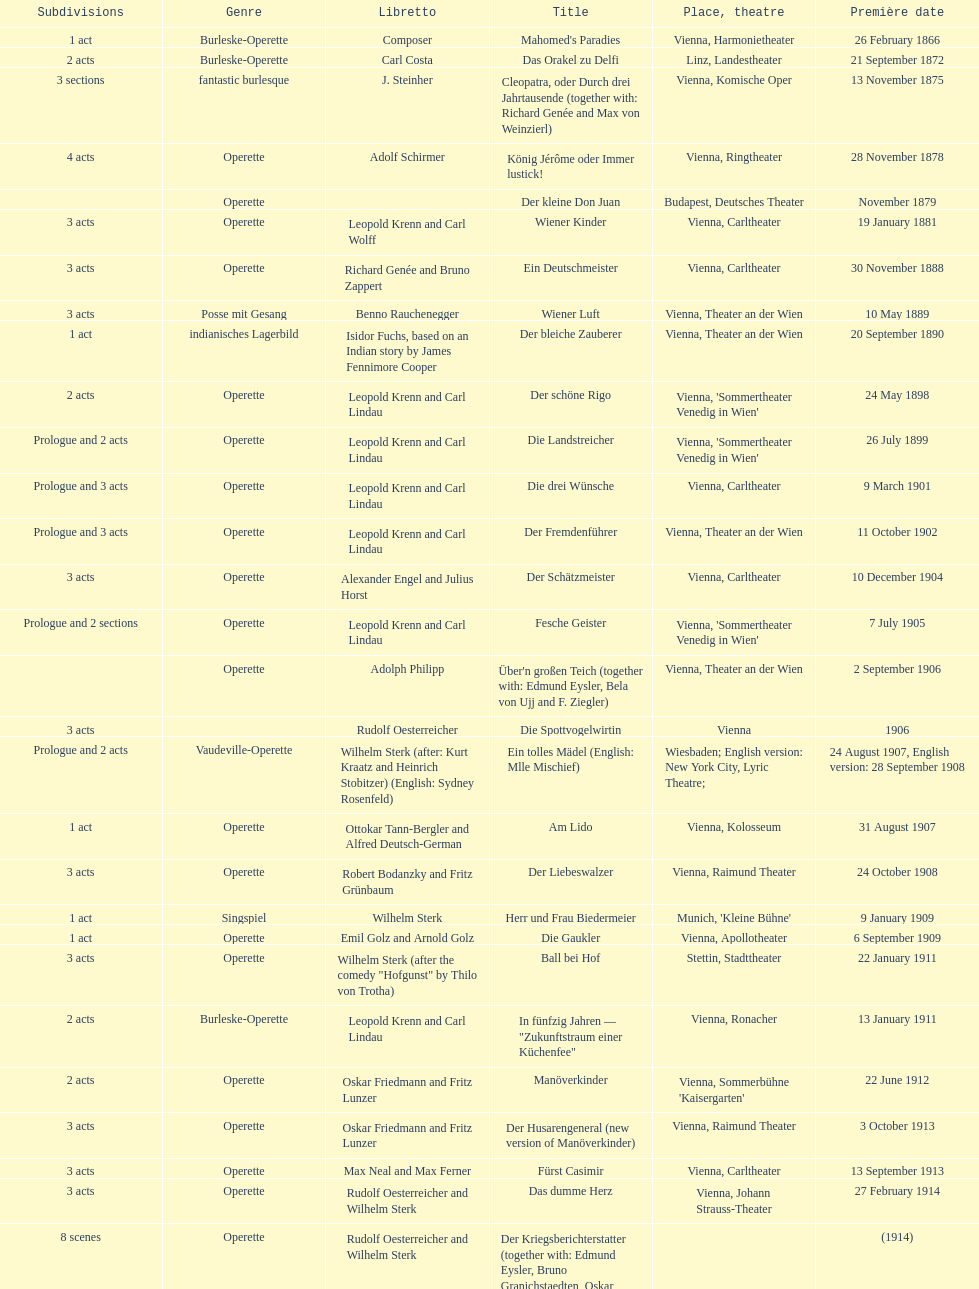In this chart, which genre is predominantly featured? Operette. 